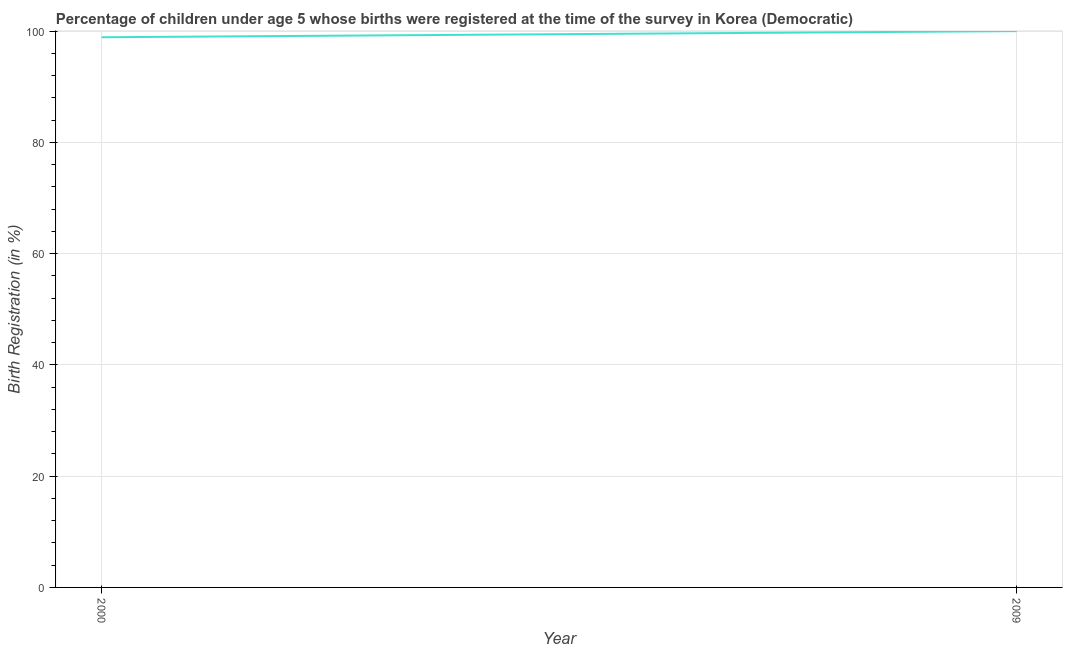What is the birth registration in 2000?
Your answer should be very brief. 98.9. Across all years, what is the maximum birth registration?
Keep it short and to the point. 100. Across all years, what is the minimum birth registration?
Keep it short and to the point. 98.9. In which year was the birth registration maximum?
Offer a terse response. 2009. In which year was the birth registration minimum?
Offer a very short reply. 2000. What is the sum of the birth registration?
Provide a succinct answer. 198.9. What is the difference between the birth registration in 2000 and 2009?
Your answer should be very brief. -1.1. What is the average birth registration per year?
Provide a succinct answer. 99.45. What is the median birth registration?
Your answer should be compact. 99.45. In how many years, is the birth registration greater than 56 %?
Provide a succinct answer. 2. Do a majority of the years between 2009 and 2000 (inclusive) have birth registration greater than 76 %?
Offer a very short reply. No. What is the ratio of the birth registration in 2000 to that in 2009?
Provide a short and direct response. 0.99. How many years are there in the graph?
Keep it short and to the point. 2. Are the values on the major ticks of Y-axis written in scientific E-notation?
Your answer should be very brief. No. Does the graph contain grids?
Your answer should be very brief. Yes. What is the title of the graph?
Your answer should be compact. Percentage of children under age 5 whose births were registered at the time of the survey in Korea (Democratic). What is the label or title of the X-axis?
Your response must be concise. Year. What is the label or title of the Y-axis?
Keep it short and to the point. Birth Registration (in %). What is the Birth Registration (in %) in 2000?
Give a very brief answer. 98.9. What is the Birth Registration (in %) in 2009?
Your answer should be very brief. 100. What is the difference between the Birth Registration (in %) in 2000 and 2009?
Your answer should be compact. -1.1. 